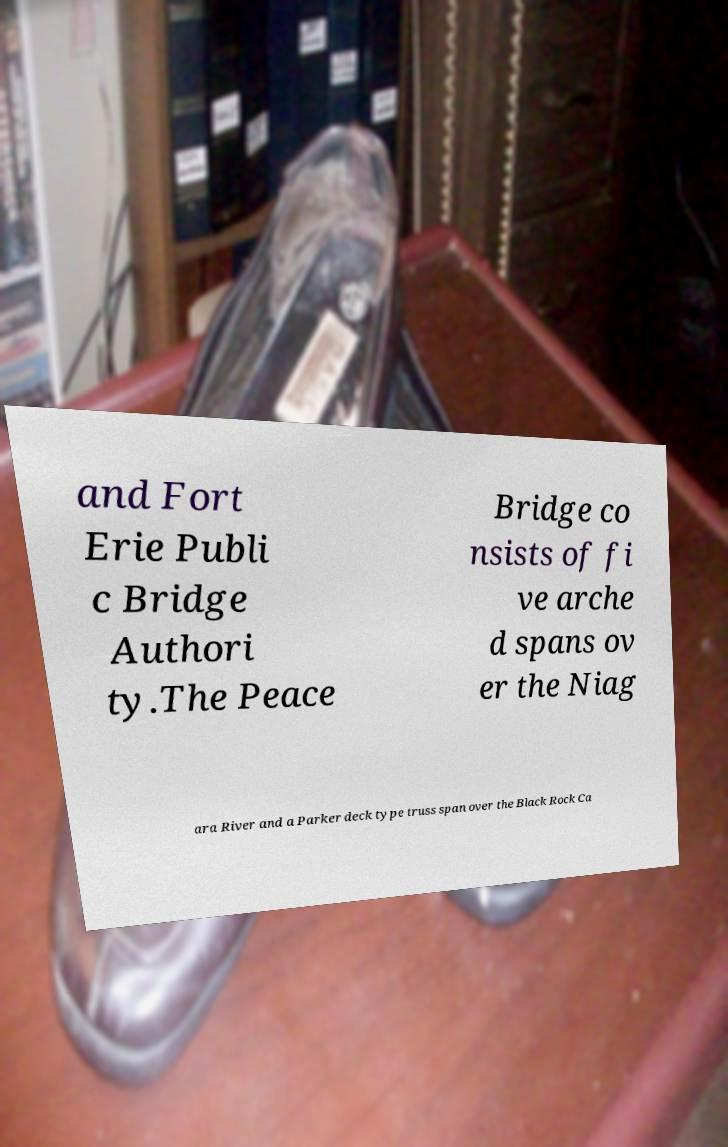What messages or text are displayed in this image? I need them in a readable, typed format. and Fort Erie Publi c Bridge Authori ty.The Peace Bridge co nsists of fi ve arche d spans ov er the Niag ara River and a Parker deck type truss span over the Black Rock Ca 